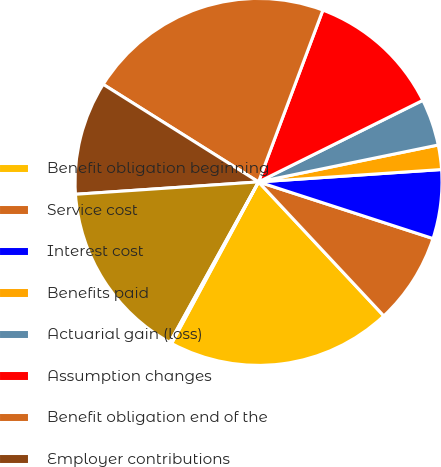<chart> <loc_0><loc_0><loc_500><loc_500><pie_chart><fcel>Benefit obligation beginning<fcel>Service cost<fcel>Interest cost<fcel>Benefits paid<fcel>Actuarial gain (loss)<fcel>Assumption changes<fcel>Benefit obligation end of the<fcel>Employer contributions<fcel>Funded Status of the plans<fcel>Pension and retirement<nl><fcel>19.82%<fcel>8.04%<fcel>6.07%<fcel>2.15%<fcel>4.11%<fcel>11.96%<fcel>21.78%<fcel>10.0%<fcel>15.89%<fcel>0.18%<nl></chart> 